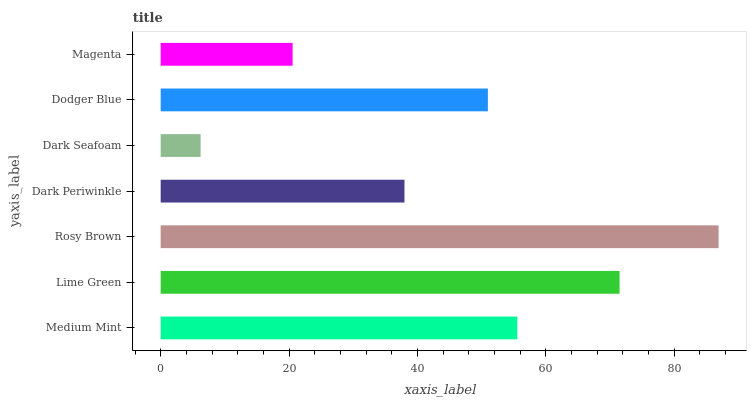Is Dark Seafoam the minimum?
Answer yes or no. Yes. Is Rosy Brown the maximum?
Answer yes or no. Yes. Is Lime Green the minimum?
Answer yes or no. No. Is Lime Green the maximum?
Answer yes or no. No. Is Lime Green greater than Medium Mint?
Answer yes or no. Yes. Is Medium Mint less than Lime Green?
Answer yes or no. Yes. Is Medium Mint greater than Lime Green?
Answer yes or no. No. Is Lime Green less than Medium Mint?
Answer yes or no. No. Is Dodger Blue the high median?
Answer yes or no. Yes. Is Dodger Blue the low median?
Answer yes or no. Yes. Is Medium Mint the high median?
Answer yes or no. No. Is Dark Seafoam the low median?
Answer yes or no. No. 